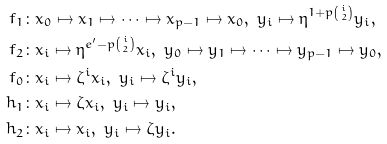Convert formula to latex. <formula><loc_0><loc_0><loc_500><loc_500>f _ { 1 } & \colon x _ { 0 } \mapsto x _ { 1 } \mapsto \cdots \mapsto x _ { p - 1 } \mapsto x _ { 0 } , \ y _ { i } \mapsto \eta ^ { 1 + p \binom { i } { 2 } } y _ { i } , \\ f _ { 2 } & \colon x _ { i } \mapsto \eta ^ { e ^ { \prime } - p \binom { i } { 2 } } x _ { i } , \ y _ { 0 } \mapsto y _ { 1 } \mapsto \cdots \mapsto y _ { p - 1 } \mapsto y _ { 0 } , \\ f _ { 0 } & \colon x _ { i } \mapsto \zeta ^ { i } x _ { i } , \ y _ { i } \mapsto \zeta ^ { i } y _ { i } , \\ h _ { 1 } & \colon x _ { i } \mapsto \zeta x _ { i } , \ y _ { i } \mapsto y _ { i } , \\ h _ { 2 } & \colon x _ { i } \mapsto x _ { i } , \ y _ { i } \mapsto \zeta y _ { i } .</formula> 